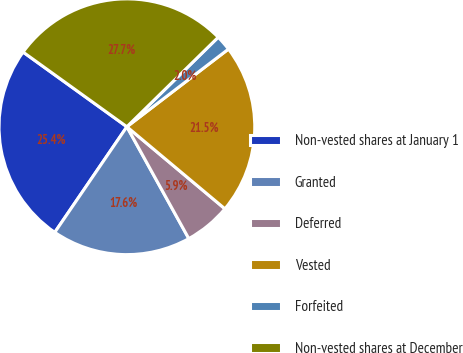<chart> <loc_0><loc_0><loc_500><loc_500><pie_chart><fcel>Non-vested shares at January 1<fcel>Granted<fcel>Deferred<fcel>Vested<fcel>Forfeited<fcel>Non-vested shares at December<nl><fcel>25.39%<fcel>17.58%<fcel>5.86%<fcel>21.48%<fcel>1.95%<fcel>27.73%<nl></chart> 